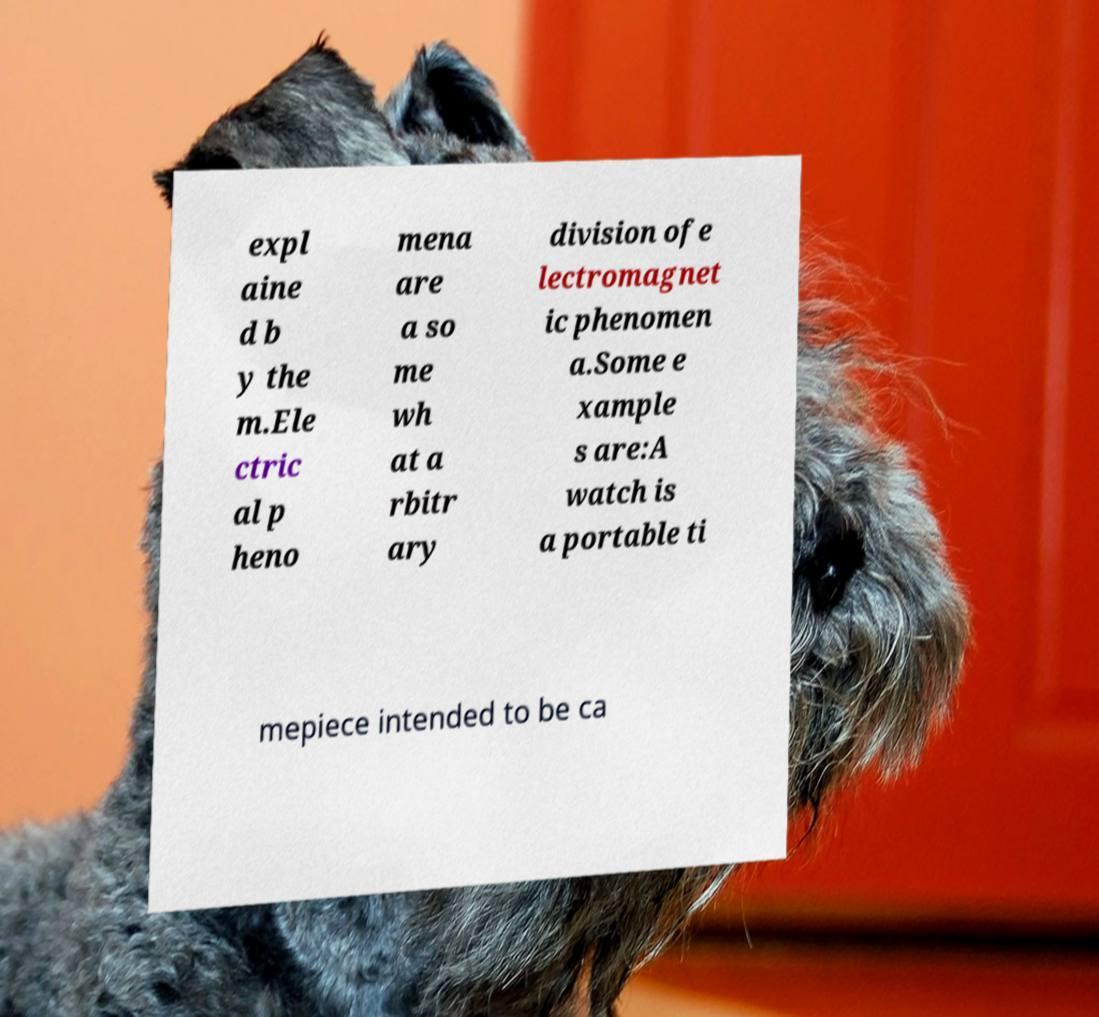What messages or text are displayed in this image? I need them in a readable, typed format. expl aine d b y the m.Ele ctric al p heno mena are a so me wh at a rbitr ary division ofe lectromagnet ic phenomen a.Some e xample s are:A watch is a portable ti mepiece intended to be ca 